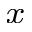Convert formula to latex. <formula><loc_0><loc_0><loc_500><loc_500>_ { x }</formula> 